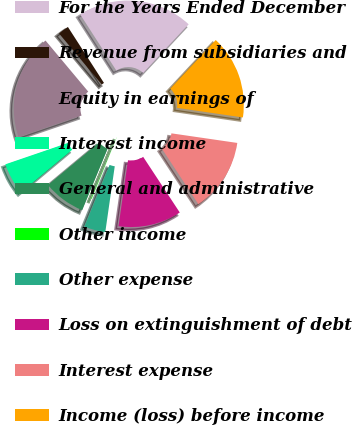Convert chart to OTSL. <chart><loc_0><loc_0><loc_500><loc_500><pie_chart><fcel>For the Years Ended December<fcel>Revenue from subsidiaries and<fcel>Equity in earnings of<fcel>Interest income<fcel>General and administrative<fcel>Other income<fcel>Other expense<fcel>Loss on extinguishment of debt<fcel>Interest expense<fcel>Income (loss) before income<nl><fcel>21.07%<fcel>1.98%<fcel>19.16%<fcel>5.8%<fcel>7.71%<fcel>0.08%<fcel>3.89%<fcel>11.53%<fcel>13.44%<fcel>15.34%<nl></chart> 